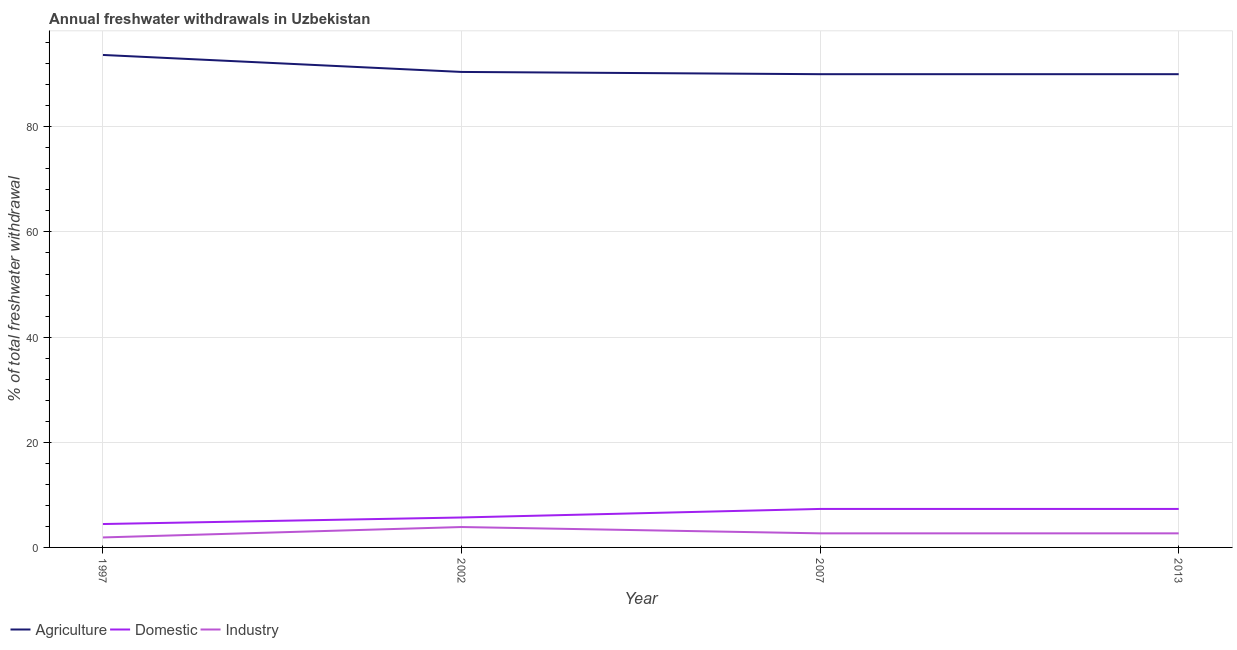How many different coloured lines are there?
Ensure brevity in your answer.  3. Does the line corresponding to percentage of freshwater withdrawal for industry intersect with the line corresponding to percentage of freshwater withdrawal for agriculture?
Your response must be concise. No. What is the percentage of freshwater withdrawal for domestic purposes in 1997?
Ensure brevity in your answer.  4.45. Across all years, what is the maximum percentage of freshwater withdrawal for domestic purposes?
Offer a very short reply. 7.32. Across all years, what is the minimum percentage of freshwater withdrawal for domestic purposes?
Keep it short and to the point. 4.45. What is the total percentage of freshwater withdrawal for agriculture in the graph?
Provide a succinct answer. 364.09. What is the difference between the percentage of freshwater withdrawal for domestic purposes in 2002 and that in 2013?
Your answer should be very brief. -1.63. What is the difference between the percentage of freshwater withdrawal for industry in 2007 and the percentage of freshwater withdrawal for domestic purposes in 1997?
Provide a succinct answer. -1.77. What is the average percentage of freshwater withdrawal for domestic purposes per year?
Offer a terse response. 6.2. In the year 2007, what is the difference between the percentage of freshwater withdrawal for agriculture and percentage of freshwater withdrawal for industry?
Your response must be concise. 87.32. In how many years, is the percentage of freshwater withdrawal for domestic purposes greater than 84 %?
Offer a terse response. 0. What is the ratio of the percentage of freshwater withdrawal for agriculture in 1997 to that in 2013?
Ensure brevity in your answer.  1.04. Is the percentage of freshwater withdrawal for agriculture in 1997 less than that in 2013?
Provide a succinct answer. No. What is the difference between the highest and the second highest percentage of freshwater withdrawal for domestic purposes?
Give a very brief answer. 0. What is the difference between the highest and the lowest percentage of freshwater withdrawal for industry?
Offer a terse response. 1.98. Is the sum of the percentage of freshwater withdrawal for agriculture in 1997 and 2007 greater than the maximum percentage of freshwater withdrawal for industry across all years?
Your answer should be compact. Yes. Is it the case that in every year, the sum of the percentage of freshwater withdrawal for agriculture and percentage of freshwater withdrawal for domestic purposes is greater than the percentage of freshwater withdrawal for industry?
Your answer should be compact. Yes. Is the percentage of freshwater withdrawal for industry strictly greater than the percentage of freshwater withdrawal for domestic purposes over the years?
Offer a terse response. No. How many lines are there?
Your answer should be compact. 3. Does the graph contain grids?
Provide a succinct answer. Yes. Where does the legend appear in the graph?
Make the answer very short. Bottom left. How many legend labels are there?
Ensure brevity in your answer.  3. What is the title of the graph?
Make the answer very short. Annual freshwater withdrawals in Uzbekistan. Does "Social Protection" appear as one of the legend labels in the graph?
Offer a very short reply. No. What is the label or title of the X-axis?
Provide a short and direct response. Year. What is the label or title of the Y-axis?
Provide a succinct answer. % of total freshwater withdrawal. What is the % of total freshwater withdrawal in Agriculture in 1997?
Provide a short and direct response. 93.66. What is the % of total freshwater withdrawal in Domestic in 1997?
Offer a terse response. 4.45. What is the % of total freshwater withdrawal in Industry in 1997?
Your answer should be very brief. 1.9. What is the % of total freshwater withdrawal of Agriculture in 2002?
Your answer should be compact. 90.43. What is the % of total freshwater withdrawal of Domestic in 2002?
Give a very brief answer. 5.7. What is the % of total freshwater withdrawal in Industry in 2002?
Provide a succinct answer. 3.88. What is the % of total freshwater withdrawal of Domestic in 2007?
Ensure brevity in your answer.  7.32. What is the % of total freshwater withdrawal of Industry in 2007?
Your response must be concise. 2.68. What is the % of total freshwater withdrawal in Agriculture in 2013?
Offer a very short reply. 90. What is the % of total freshwater withdrawal in Domestic in 2013?
Ensure brevity in your answer.  7.32. What is the % of total freshwater withdrawal of Industry in 2013?
Your answer should be compact. 2.68. Across all years, what is the maximum % of total freshwater withdrawal of Agriculture?
Provide a succinct answer. 93.66. Across all years, what is the maximum % of total freshwater withdrawal of Domestic?
Ensure brevity in your answer.  7.32. Across all years, what is the maximum % of total freshwater withdrawal of Industry?
Your answer should be compact. 3.88. Across all years, what is the minimum % of total freshwater withdrawal in Agriculture?
Your response must be concise. 90. Across all years, what is the minimum % of total freshwater withdrawal of Domestic?
Ensure brevity in your answer.  4.45. What is the total % of total freshwater withdrawal in Agriculture in the graph?
Your response must be concise. 364.09. What is the total % of total freshwater withdrawal in Domestic in the graph?
Keep it short and to the point. 24.79. What is the total % of total freshwater withdrawal in Industry in the graph?
Your response must be concise. 11.14. What is the difference between the % of total freshwater withdrawal in Agriculture in 1997 and that in 2002?
Give a very brief answer. 3.23. What is the difference between the % of total freshwater withdrawal in Domestic in 1997 and that in 2002?
Provide a succinct answer. -1.25. What is the difference between the % of total freshwater withdrawal in Industry in 1997 and that in 2002?
Your answer should be very brief. -1.98. What is the difference between the % of total freshwater withdrawal of Agriculture in 1997 and that in 2007?
Make the answer very short. 3.66. What is the difference between the % of total freshwater withdrawal of Domestic in 1997 and that in 2007?
Keep it short and to the point. -2.87. What is the difference between the % of total freshwater withdrawal of Industry in 1997 and that in 2007?
Your response must be concise. -0.78. What is the difference between the % of total freshwater withdrawal of Agriculture in 1997 and that in 2013?
Give a very brief answer. 3.66. What is the difference between the % of total freshwater withdrawal of Domestic in 1997 and that in 2013?
Make the answer very short. -2.87. What is the difference between the % of total freshwater withdrawal in Industry in 1997 and that in 2013?
Keep it short and to the point. -0.78. What is the difference between the % of total freshwater withdrawal in Agriculture in 2002 and that in 2007?
Provide a succinct answer. 0.43. What is the difference between the % of total freshwater withdrawal of Domestic in 2002 and that in 2007?
Your response must be concise. -1.63. What is the difference between the % of total freshwater withdrawal of Industry in 2002 and that in 2007?
Your answer should be compact. 1.2. What is the difference between the % of total freshwater withdrawal of Agriculture in 2002 and that in 2013?
Provide a short and direct response. 0.43. What is the difference between the % of total freshwater withdrawal in Domestic in 2002 and that in 2013?
Give a very brief answer. -1.63. What is the difference between the % of total freshwater withdrawal in Domestic in 2007 and that in 2013?
Your answer should be very brief. 0. What is the difference between the % of total freshwater withdrawal of Agriculture in 1997 and the % of total freshwater withdrawal of Domestic in 2002?
Give a very brief answer. 87.97. What is the difference between the % of total freshwater withdrawal of Agriculture in 1997 and the % of total freshwater withdrawal of Industry in 2002?
Your answer should be very brief. 89.78. What is the difference between the % of total freshwater withdrawal of Domestic in 1997 and the % of total freshwater withdrawal of Industry in 2002?
Provide a short and direct response. 0.57. What is the difference between the % of total freshwater withdrawal of Agriculture in 1997 and the % of total freshwater withdrawal of Domestic in 2007?
Your answer should be very brief. 86.34. What is the difference between the % of total freshwater withdrawal of Agriculture in 1997 and the % of total freshwater withdrawal of Industry in 2007?
Provide a short and direct response. 90.98. What is the difference between the % of total freshwater withdrawal of Domestic in 1997 and the % of total freshwater withdrawal of Industry in 2007?
Ensure brevity in your answer.  1.77. What is the difference between the % of total freshwater withdrawal in Agriculture in 1997 and the % of total freshwater withdrawal in Domestic in 2013?
Provide a short and direct response. 86.34. What is the difference between the % of total freshwater withdrawal in Agriculture in 1997 and the % of total freshwater withdrawal in Industry in 2013?
Your answer should be compact. 90.98. What is the difference between the % of total freshwater withdrawal in Domestic in 1997 and the % of total freshwater withdrawal in Industry in 2013?
Provide a succinct answer. 1.77. What is the difference between the % of total freshwater withdrawal of Agriculture in 2002 and the % of total freshwater withdrawal of Domestic in 2007?
Offer a very short reply. 83.11. What is the difference between the % of total freshwater withdrawal in Agriculture in 2002 and the % of total freshwater withdrawal in Industry in 2007?
Provide a short and direct response. 87.75. What is the difference between the % of total freshwater withdrawal in Domestic in 2002 and the % of total freshwater withdrawal in Industry in 2007?
Provide a short and direct response. 3.02. What is the difference between the % of total freshwater withdrawal of Agriculture in 2002 and the % of total freshwater withdrawal of Domestic in 2013?
Give a very brief answer. 83.11. What is the difference between the % of total freshwater withdrawal in Agriculture in 2002 and the % of total freshwater withdrawal in Industry in 2013?
Give a very brief answer. 87.75. What is the difference between the % of total freshwater withdrawal of Domestic in 2002 and the % of total freshwater withdrawal of Industry in 2013?
Provide a short and direct response. 3.02. What is the difference between the % of total freshwater withdrawal of Agriculture in 2007 and the % of total freshwater withdrawal of Domestic in 2013?
Offer a terse response. 82.68. What is the difference between the % of total freshwater withdrawal in Agriculture in 2007 and the % of total freshwater withdrawal in Industry in 2013?
Your answer should be compact. 87.32. What is the difference between the % of total freshwater withdrawal of Domestic in 2007 and the % of total freshwater withdrawal of Industry in 2013?
Offer a very short reply. 4.64. What is the average % of total freshwater withdrawal of Agriculture per year?
Ensure brevity in your answer.  91.02. What is the average % of total freshwater withdrawal in Domestic per year?
Offer a very short reply. 6.2. What is the average % of total freshwater withdrawal of Industry per year?
Your response must be concise. 2.78. In the year 1997, what is the difference between the % of total freshwater withdrawal of Agriculture and % of total freshwater withdrawal of Domestic?
Keep it short and to the point. 89.21. In the year 1997, what is the difference between the % of total freshwater withdrawal in Agriculture and % of total freshwater withdrawal in Industry?
Keep it short and to the point. 91.76. In the year 1997, what is the difference between the % of total freshwater withdrawal in Domestic and % of total freshwater withdrawal in Industry?
Ensure brevity in your answer.  2.55. In the year 2002, what is the difference between the % of total freshwater withdrawal of Agriculture and % of total freshwater withdrawal of Domestic?
Your answer should be very brief. 84.73. In the year 2002, what is the difference between the % of total freshwater withdrawal in Agriculture and % of total freshwater withdrawal in Industry?
Make the answer very short. 86.55. In the year 2002, what is the difference between the % of total freshwater withdrawal in Domestic and % of total freshwater withdrawal in Industry?
Provide a short and direct response. 1.82. In the year 2007, what is the difference between the % of total freshwater withdrawal of Agriculture and % of total freshwater withdrawal of Domestic?
Provide a short and direct response. 82.68. In the year 2007, what is the difference between the % of total freshwater withdrawal of Agriculture and % of total freshwater withdrawal of Industry?
Your answer should be compact. 87.32. In the year 2007, what is the difference between the % of total freshwater withdrawal in Domestic and % of total freshwater withdrawal in Industry?
Offer a terse response. 4.64. In the year 2013, what is the difference between the % of total freshwater withdrawal of Agriculture and % of total freshwater withdrawal of Domestic?
Ensure brevity in your answer.  82.68. In the year 2013, what is the difference between the % of total freshwater withdrawal of Agriculture and % of total freshwater withdrawal of Industry?
Your response must be concise. 87.32. In the year 2013, what is the difference between the % of total freshwater withdrawal of Domestic and % of total freshwater withdrawal of Industry?
Keep it short and to the point. 4.64. What is the ratio of the % of total freshwater withdrawal in Agriculture in 1997 to that in 2002?
Provide a short and direct response. 1.04. What is the ratio of the % of total freshwater withdrawal in Domestic in 1997 to that in 2002?
Ensure brevity in your answer.  0.78. What is the ratio of the % of total freshwater withdrawal in Industry in 1997 to that in 2002?
Offer a terse response. 0.49. What is the ratio of the % of total freshwater withdrawal in Agriculture in 1997 to that in 2007?
Your answer should be very brief. 1.04. What is the ratio of the % of total freshwater withdrawal in Domestic in 1997 to that in 2007?
Your response must be concise. 0.61. What is the ratio of the % of total freshwater withdrawal of Industry in 1997 to that in 2007?
Offer a very short reply. 0.71. What is the ratio of the % of total freshwater withdrawal in Agriculture in 1997 to that in 2013?
Offer a very short reply. 1.04. What is the ratio of the % of total freshwater withdrawal in Domestic in 1997 to that in 2013?
Offer a very short reply. 0.61. What is the ratio of the % of total freshwater withdrawal in Industry in 1997 to that in 2013?
Keep it short and to the point. 0.71. What is the ratio of the % of total freshwater withdrawal in Agriculture in 2002 to that in 2007?
Give a very brief answer. 1. What is the ratio of the % of total freshwater withdrawal of Domestic in 2002 to that in 2007?
Give a very brief answer. 0.78. What is the ratio of the % of total freshwater withdrawal of Industry in 2002 to that in 2007?
Offer a very short reply. 1.45. What is the ratio of the % of total freshwater withdrawal in Domestic in 2002 to that in 2013?
Provide a short and direct response. 0.78. What is the ratio of the % of total freshwater withdrawal of Industry in 2002 to that in 2013?
Provide a short and direct response. 1.45. What is the ratio of the % of total freshwater withdrawal of Agriculture in 2007 to that in 2013?
Your answer should be very brief. 1. What is the difference between the highest and the second highest % of total freshwater withdrawal of Agriculture?
Ensure brevity in your answer.  3.23. What is the difference between the highest and the lowest % of total freshwater withdrawal of Agriculture?
Make the answer very short. 3.66. What is the difference between the highest and the lowest % of total freshwater withdrawal of Domestic?
Your response must be concise. 2.87. What is the difference between the highest and the lowest % of total freshwater withdrawal in Industry?
Ensure brevity in your answer.  1.98. 